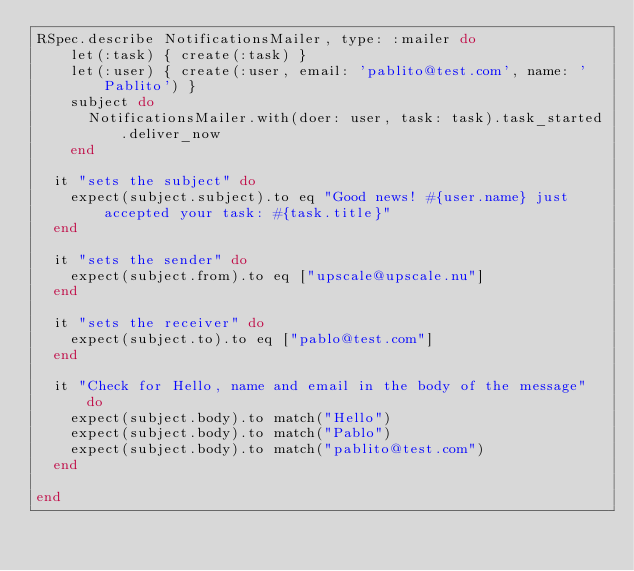Convert code to text. <code><loc_0><loc_0><loc_500><loc_500><_Ruby_>RSpec.describe NotificationsMailer, type: :mailer do
    let(:task) { create(:task) }
    let(:user) { create(:user, email: 'pablito@test.com', name: 'Pablito') }
    subject do
      NotificationsMailer.with(doer: user, task: task).task_started.deliver_now
    end

  it "sets the subject" do
    expect(subject.subject).to eq "Good news! #{user.name} just accepted your task: #{task.title}"
  end

  it "sets the sender" do
    expect(subject.from).to eq ["upscale@upscale.nu"]
  end

  it "sets the receiver" do
    expect(subject.to).to eq ["pablo@test.com"]
  end

  it "Check for Hello, name and email in the body of the message" do
    expect(subject.body).to match("Hello")
    expect(subject.body).to match("Pablo")
    expect(subject.body).to match("pablito@test.com")
  end

end</code> 